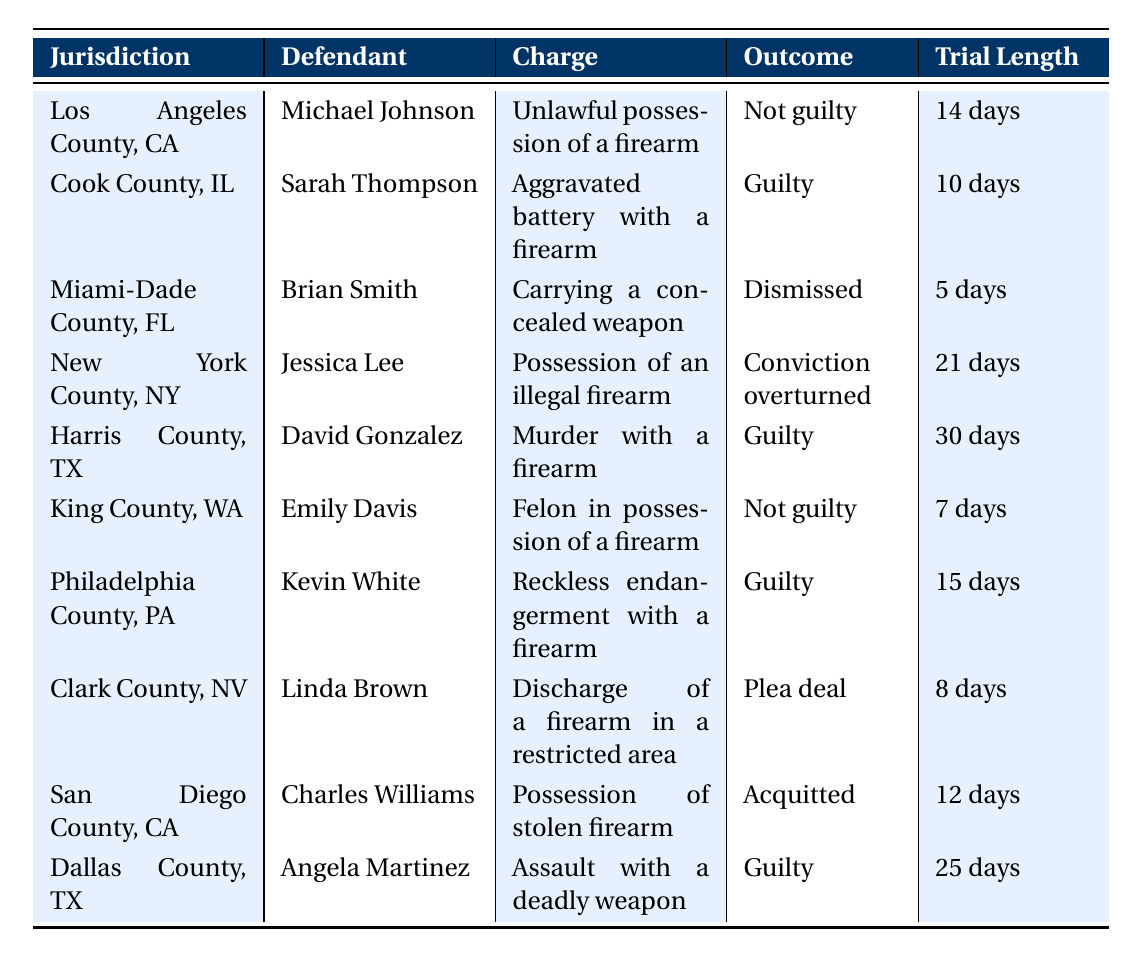What is the outcome for the case involving Michael Johnson in Los Angeles County? The table lists Michael Johnson’s case under Los Angeles County, where the outcome is stated as "Not guilty."
Answer: Not guilty How many days did the trial for Jessica Lee in New York County last? The duration of Jessica Lee's trial, as indicated in the table, is 21 days.
Answer: 21 days Which jurisdiction had a guilty outcome for a charge of murder with a firearm? The table shows that the case for David Gonzalez in Harris County had a guilty outcome for the charge of murder with a firearm.
Answer: Harris County, TX What was the defense strategy used by Angela Martinez during her trial? The table specifies that Angela Martinez's defense strategy was a psychological evaluation.
Answer: Psychological evaluation Which case had the shortest trial length and what was the outcome? According to the table, Brian Smith's case in Miami-Dade County had the shortest trial length of 5 days, and the outcome was "Dismissed."
Answer: 5 days, Dismissed How many cases listed in the table ended with a guilty verdict? The table can be analyzed by counting the outcomes marked as "Guilty," which occurs for Sarah Thompson, David Gonzalez, Kevin White, and Angela Martinez, totaling 4 guilty outcomes.
Answer: 4 What was the outcome for the charge of possession of an illegal firearm in New York County? The outcome listed for Jessica Lee's case in New York County for possession of an illegal firearm is "Conviction overturned."
Answer: Conviction overturned Is there a case in San Diego County with a not guilty verdict? Checking the outcomes listed, the case of Charles Williams in San Diego County is marked as "Acquitted," which is similar to a not guilty verdict.
Answer: Yes Which defense strategy was employed in the case involving Linda Brown in Clark County? The table indicates that Linda Brown's defense strategy involved cooperation with authorities.
Answer: Cooperation with authorities What is the average trial length of cases that resulted in a guilty verdict? To find the average, sum the trial lengths of the guilty cases: 10 (Sarah Thompson) + 30 (David Gonzalez) + 15 (Kevin White) + 25 (Angela Martinez) equals 80 days. There are 4 guilty cases, so the average is 80/4 = 20 days.
Answer: 20 days In how many cases did defendants claim self-defense as their defense strategy? Analyzing the table, David Gonzalez claimed self-defense in his murder case and is the only case that reflects this defense strategy.
Answer: 1 